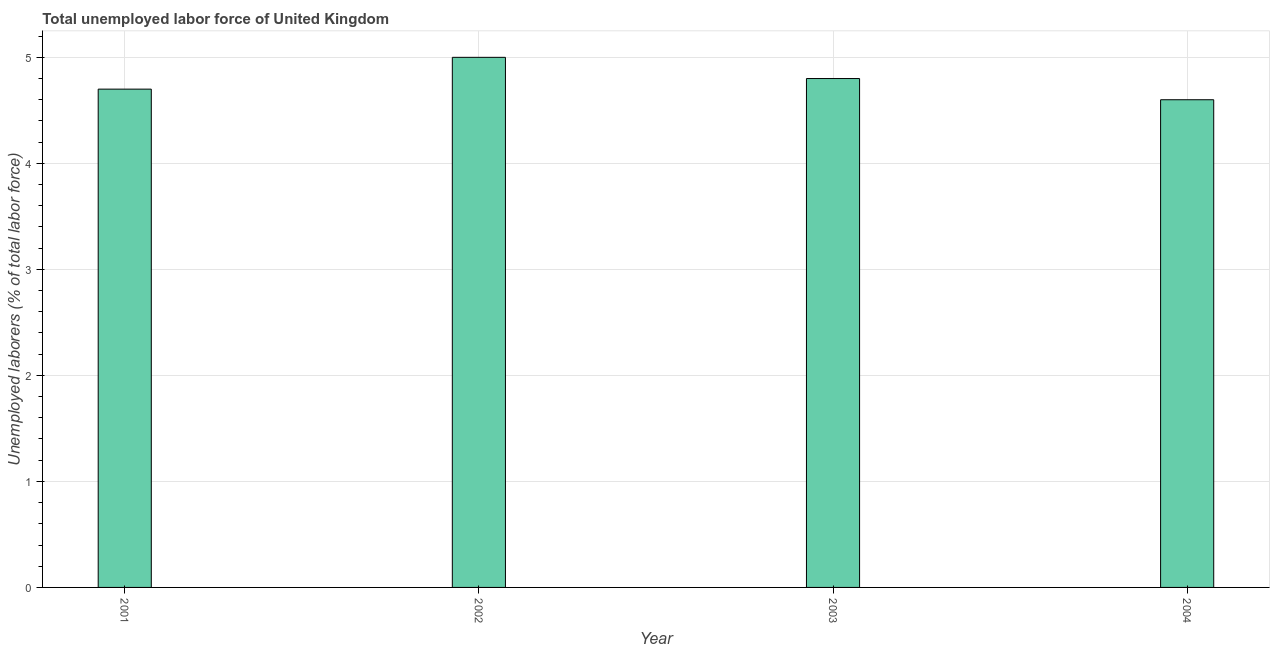Does the graph contain grids?
Keep it short and to the point. Yes. What is the title of the graph?
Ensure brevity in your answer.  Total unemployed labor force of United Kingdom. What is the label or title of the Y-axis?
Give a very brief answer. Unemployed laborers (% of total labor force). What is the total unemployed labour force in 2003?
Offer a very short reply. 4.8. Across all years, what is the minimum total unemployed labour force?
Your answer should be compact. 4.6. In which year was the total unemployed labour force maximum?
Give a very brief answer. 2002. In which year was the total unemployed labour force minimum?
Your response must be concise. 2004. What is the sum of the total unemployed labour force?
Your answer should be very brief. 19.1. What is the difference between the total unemployed labour force in 2001 and 2003?
Give a very brief answer. -0.1. What is the average total unemployed labour force per year?
Give a very brief answer. 4.78. What is the median total unemployed labour force?
Offer a terse response. 4.75. In how many years, is the total unemployed labour force greater than 2.2 %?
Keep it short and to the point. 4. Do a majority of the years between 2002 and 2001 (inclusive) have total unemployed labour force greater than 1.8 %?
Offer a very short reply. No. What is the ratio of the total unemployed labour force in 2003 to that in 2004?
Offer a very short reply. 1.04. Is the total unemployed labour force in 2001 less than that in 2002?
Ensure brevity in your answer.  Yes. Is the sum of the total unemployed labour force in 2002 and 2003 greater than the maximum total unemployed labour force across all years?
Provide a succinct answer. Yes. In how many years, is the total unemployed labour force greater than the average total unemployed labour force taken over all years?
Offer a very short reply. 2. How many bars are there?
Provide a short and direct response. 4. Are all the bars in the graph horizontal?
Keep it short and to the point. No. What is the difference between two consecutive major ticks on the Y-axis?
Make the answer very short. 1. Are the values on the major ticks of Y-axis written in scientific E-notation?
Your answer should be compact. No. What is the Unemployed laborers (% of total labor force) in 2001?
Provide a succinct answer. 4.7. What is the Unemployed laborers (% of total labor force) of 2002?
Give a very brief answer. 5. What is the Unemployed laborers (% of total labor force) in 2003?
Your response must be concise. 4.8. What is the Unemployed laborers (% of total labor force) in 2004?
Provide a succinct answer. 4.6. What is the difference between the Unemployed laborers (% of total labor force) in 2001 and 2004?
Give a very brief answer. 0.1. What is the difference between the Unemployed laborers (% of total labor force) in 2003 and 2004?
Ensure brevity in your answer.  0.2. What is the ratio of the Unemployed laborers (% of total labor force) in 2001 to that in 2002?
Keep it short and to the point. 0.94. What is the ratio of the Unemployed laborers (% of total labor force) in 2001 to that in 2003?
Your answer should be very brief. 0.98. What is the ratio of the Unemployed laborers (% of total labor force) in 2002 to that in 2003?
Your response must be concise. 1.04. What is the ratio of the Unemployed laborers (% of total labor force) in 2002 to that in 2004?
Your response must be concise. 1.09. What is the ratio of the Unemployed laborers (% of total labor force) in 2003 to that in 2004?
Make the answer very short. 1.04. 